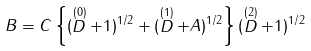<formula> <loc_0><loc_0><loc_500><loc_500>B = C \left \{ ( \stackrel { ( 0 ) } { D } + 1 ) ^ { 1 / 2 } + ( \stackrel { ( 1 ) } { D } + A ) ^ { 1 / 2 } \right \} ( \stackrel { ( 2 ) } { D } + 1 ) ^ { 1 / 2 }</formula> 